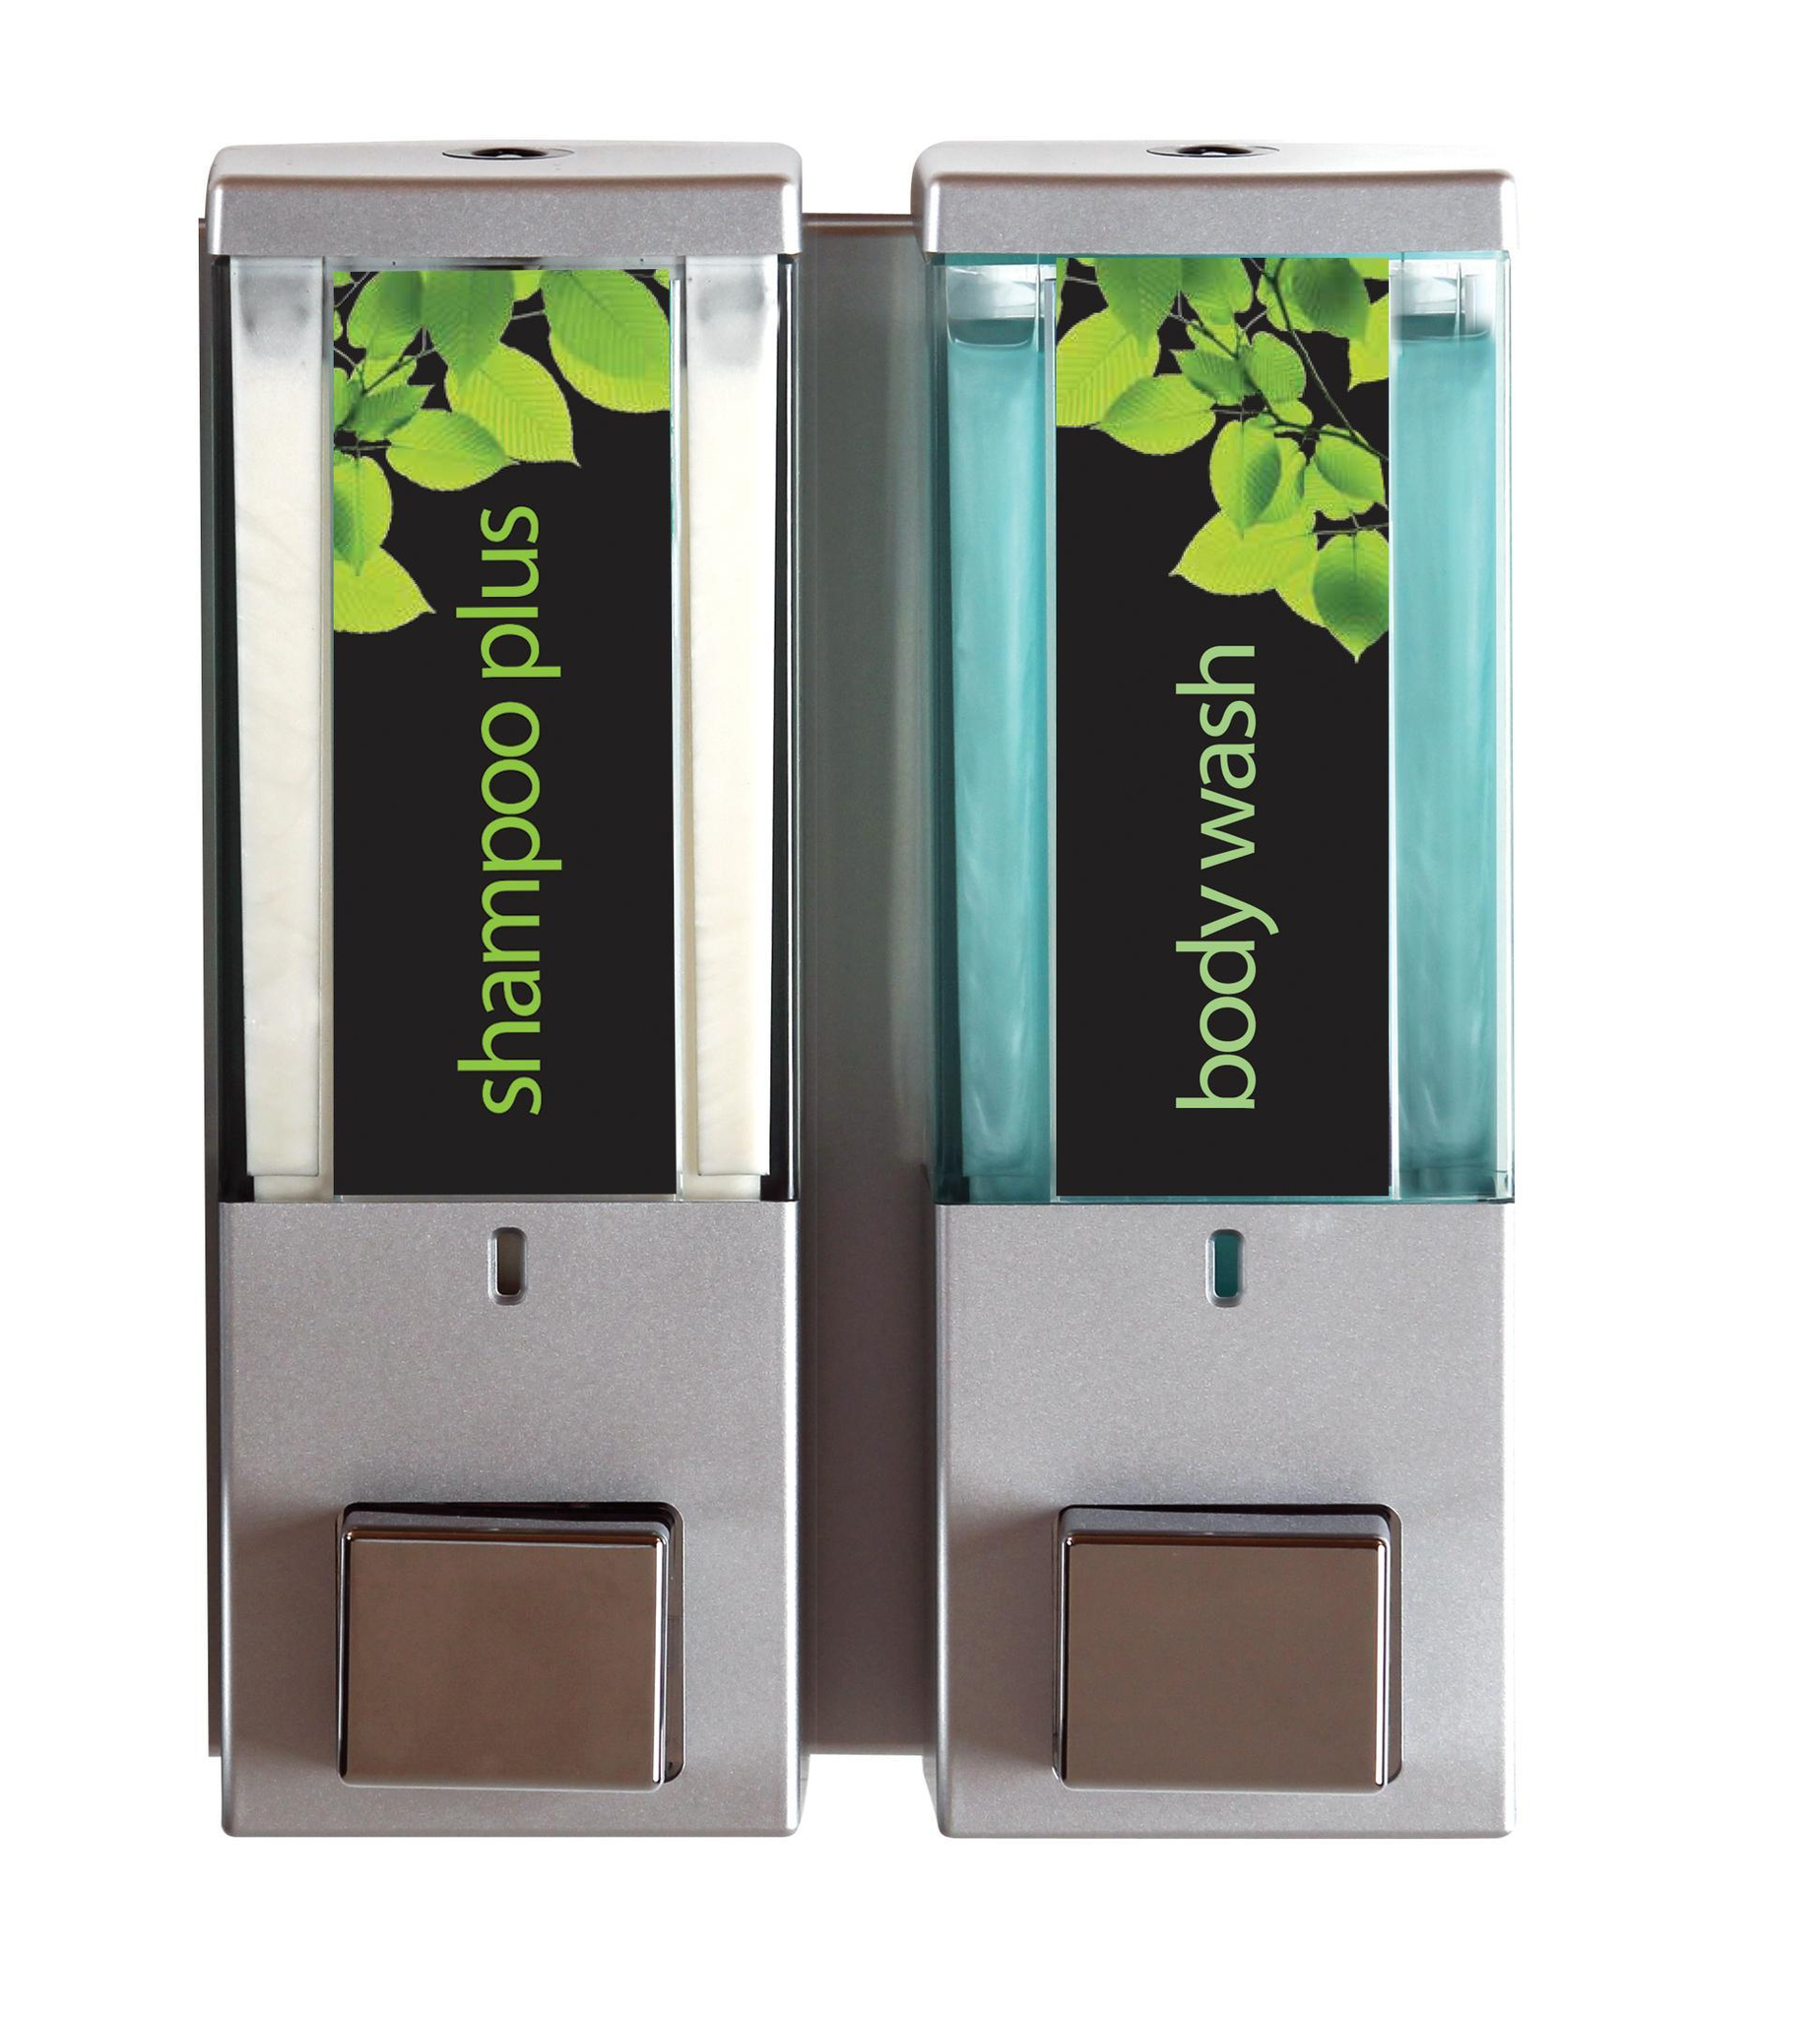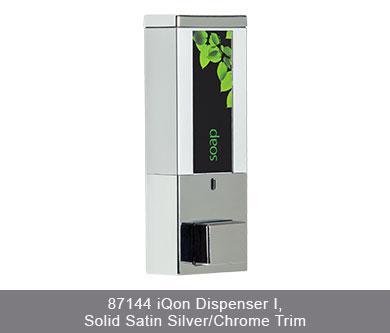The first image is the image on the left, the second image is the image on the right. Considering the images on both sides, is "There are more dispensers in the right image than in the left image." valid? Answer yes or no. No. The first image is the image on the left, the second image is the image on the right. For the images displayed, is the sentence "The left image contains both a shampoo container and a body wash container." factually correct? Answer yes or no. Yes. 